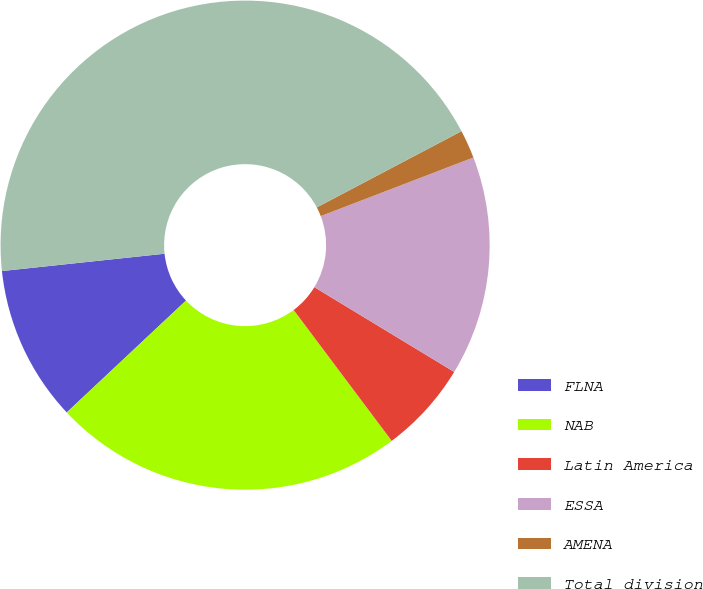Convert chart to OTSL. <chart><loc_0><loc_0><loc_500><loc_500><pie_chart><fcel>FLNA<fcel>NAB<fcel>Latin America<fcel>ESSA<fcel>AMENA<fcel>Total division<nl><fcel>10.3%<fcel>23.24%<fcel>6.09%<fcel>14.51%<fcel>1.88%<fcel>43.97%<nl></chart> 